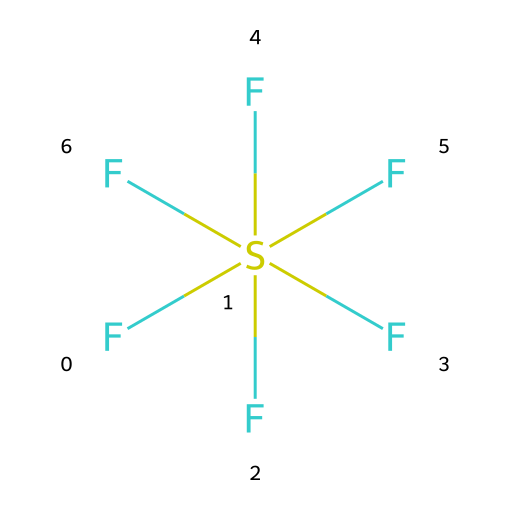What is the name of this chemical? The structure represents sulfur hexafluoride, indicated by the central sulfur atom surrounded by six fluorine atoms.
Answer: sulfur hexafluoride How many fluorine atoms are present? The chemical has six fluorine atoms directly bonded to the sulfur atom, as shown by the six F symbols in the structure.
Answer: six What is the central atom in this molecule? The structure indicates that sulfur is the central atom, as it is surrounded by the six fluorine atoms.
Answer: sulfur Is sulfur hexafluoride a reactive gas? The structure indicates that sulfur hexafluoride is inert due to its full octet configuration, making it chemically stable and non-reactive.
Answer: inert What type of bonding is present in sulfur hexafluoride? The molecule consists of covalent bonds between the sulfur atom and the fluorine atoms, where electrons are shared to form the chemical structure.
Answer: covalent What is the molecular geometry of sulfur hexafluoride? The arrangement of the six fluorine atoms around the sulfur atom creates an octahedral geometry, which is characteristic for this type of molecule.
Answer: octahedral 